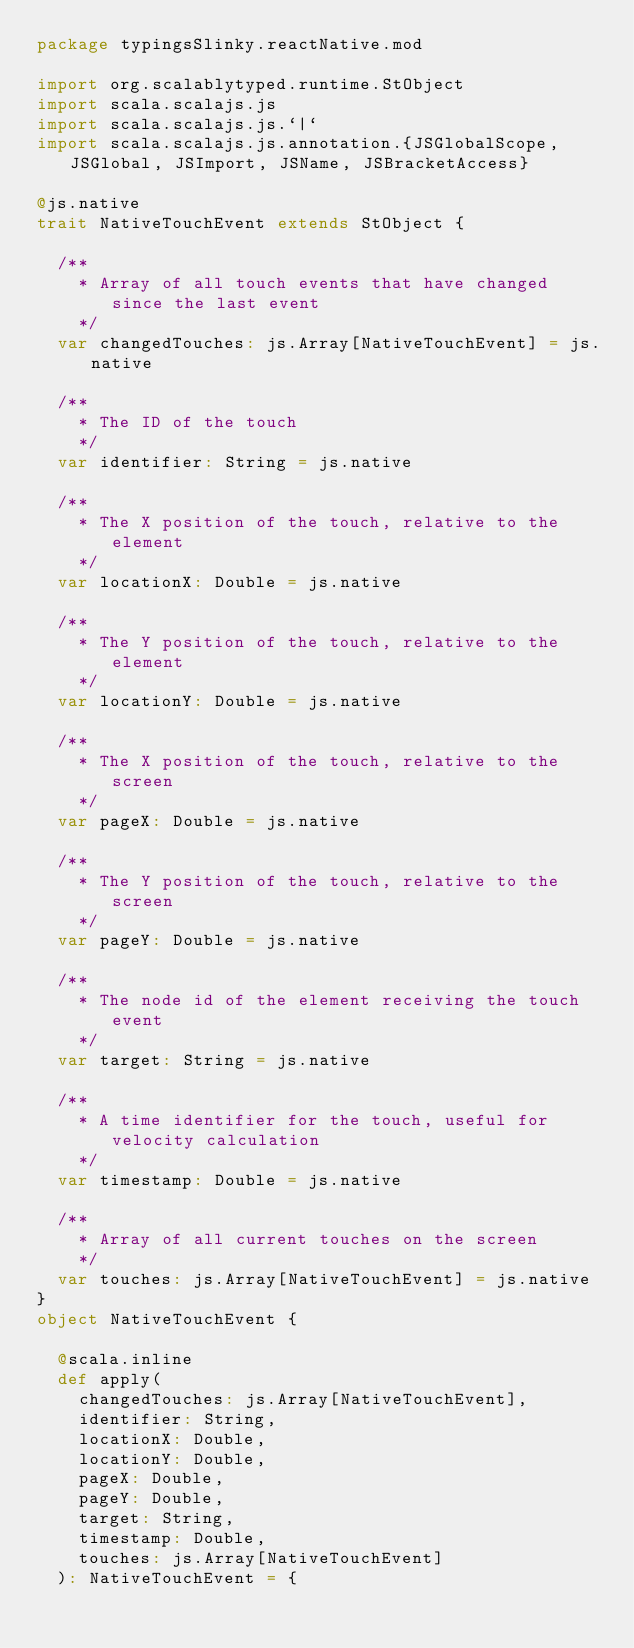Convert code to text. <code><loc_0><loc_0><loc_500><loc_500><_Scala_>package typingsSlinky.reactNative.mod

import org.scalablytyped.runtime.StObject
import scala.scalajs.js
import scala.scalajs.js.`|`
import scala.scalajs.js.annotation.{JSGlobalScope, JSGlobal, JSImport, JSName, JSBracketAccess}

@js.native
trait NativeTouchEvent extends StObject {
  
  /**
    * Array of all touch events that have changed since the last event
    */
  var changedTouches: js.Array[NativeTouchEvent] = js.native
  
  /**
    * The ID of the touch
    */
  var identifier: String = js.native
  
  /**
    * The X position of the touch, relative to the element
    */
  var locationX: Double = js.native
  
  /**
    * The Y position of the touch, relative to the element
    */
  var locationY: Double = js.native
  
  /**
    * The X position of the touch, relative to the screen
    */
  var pageX: Double = js.native
  
  /**
    * The Y position of the touch, relative to the screen
    */
  var pageY: Double = js.native
  
  /**
    * The node id of the element receiving the touch event
    */
  var target: String = js.native
  
  /**
    * A time identifier for the touch, useful for velocity calculation
    */
  var timestamp: Double = js.native
  
  /**
    * Array of all current touches on the screen
    */
  var touches: js.Array[NativeTouchEvent] = js.native
}
object NativeTouchEvent {
  
  @scala.inline
  def apply(
    changedTouches: js.Array[NativeTouchEvent],
    identifier: String,
    locationX: Double,
    locationY: Double,
    pageX: Double,
    pageY: Double,
    target: String,
    timestamp: Double,
    touches: js.Array[NativeTouchEvent]
  ): NativeTouchEvent = {</code> 